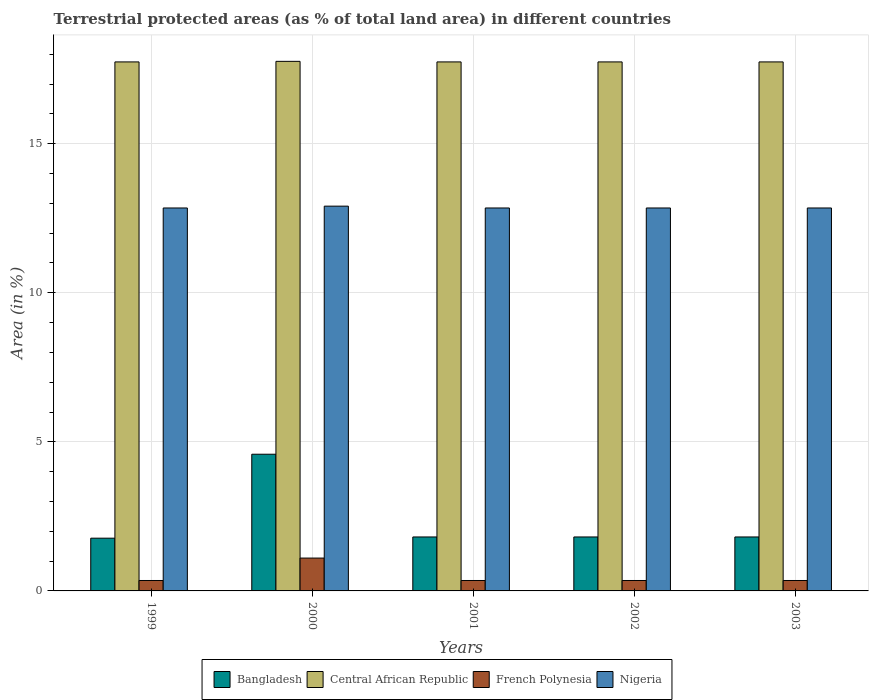Are the number of bars per tick equal to the number of legend labels?
Your answer should be compact. Yes. How many bars are there on the 5th tick from the right?
Offer a terse response. 4. In how many cases, is the number of bars for a given year not equal to the number of legend labels?
Keep it short and to the point. 0. What is the percentage of terrestrial protected land in Central African Republic in 2002?
Give a very brief answer. 17.74. Across all years, what is the maximum percentage of terrestrial protected land in Nigeria?
Your answer should be very brief. 12.91. Across all years, what is the minimum percentage of terrestrial protected land in French Polynesia?
Make the answer very short. 0.35. In which year was the percentage of terrestrial protected land in Nigeria maximum?
Your answer should be compact. 2000. What is the total percentage of terrestrial protected land in Central African Republic in the graph?
Keep it short and to the point. 88.74. What is the difference between the percentage of terrestrial protected land in Nigeria in 2001 and the percentage of terrestrial protected land in French Polynesia in 1999?
Your answer should be compact. 12.49. What is the average percentage of terrestrial protected land in Bangladesh per year?
Your answer should be very brief. 2.36. In the year 2000, what is the difference between the percentage of terrestrial protected land in Central African Republic and percentage of terrestrial protected land in Nigeria?
Your response must be concise. 4.86. What is the ratio of the percentage of terrestrial protected land in Nigeria in 1999 to that in 2002?
Keep it short and to the point. 1. Is the difference between the percentage of terrestrial protected land in Central African Republic in 2002 and 2003 greater than the difference between the percentage of terrestrial protected land in Nigeria in 2002 and 2003?
Offer a terse response. No. What is the difference between the highest and the second highest percentage of terrestrial protected land in Nigeria?
Offer a very short reply. 0.06. What is the difference between the highest and the lowest percentage of terrestrial protected land in Nigeria?
Provide a short and direct response. 0.06. Is it the case that in every year, the sum of the percentage of terrestrial protected land in Bangladesh and percentage of terrestrial protected land in Nigeria is greater than the sum of percentage of terrestrial protected land in French Polynesia and percentage of terrestrial protected land in Central African Republic?
Your response must be concise. No. What does the 1st bar from the left in 2000 represents?
Give a very brief answer. Bangladesh. What does the 3rd bar from the right in 1999 represents?
Your response must be concise. Central African Republic. How many years are there in the graph?
Your answer should be compact. 5. What is the difference between two consecutive major ticks on the Y-axis?
Offer a terse response. 5. Does the graph contain grids?
Offer a terse response. Yes. Where does the legend appear in the graph?
Ensure brevity in your answer.  Bottom center. What is the title of the graph?
Make the answer very short. Terrestrial protected areas (as % of total land area) in different countries. What is the label or title of the Y-axis?
Make the answer very short. Area (in %). What is the Area (in %) of Bangladesh in 1999?
Make the answer very short. 1.77. What is the Area (in %) of Central African Republic in 1999?
Keep it short and to the point. 17.74. What is the Area (in %) in French Polynesia in 1999?
Give a very brief answer. 0.35. What is the Area (in %) in Nigeria in 1999?
Keep it short and to the point. 12.84. What is the Area (in %) of Bangladesh in 2000?
Offer a very short reply. 4.58. What is the Area (in %) in Central African Republic in 2000?
Offer a very short reply. 17.76. What is the Area (in %) in French Polynesia in 2000?
Your answer should be very brief. 1.1. What is the Area (in %) of Nigeria in 2000?
Ensure brevity in your answer.  12.91. What is the Area (in %) of Bangladesh in 2001?
Give a very brief answer. 1.81. What is the Area (in %) in Central African Republic in 2001?
Make the answer very short. 17.74. What is the Area (in %) of French Polynesia in 2001?
Your answer should be very brief. 0.35. What is the Area (in %) of Nigeria in 2001?
Your response must be concise. 12.84. What is the Area (in %) of Bangladesh in 2002?
Your response must be concise. 1.81. What is the Area (in %) in Central African Republic in 2002?
Keep it short and to the point. 17.74. What is the Area (in %) in French Polynesia in 2002?
Ensure brevity in your answer.  0.35. What is the Area (in %) in Nigeria in 2002?
Your answer should be very brief. 12.84. What is the Area (in %) of Bangladesh in 2003?
Provide a succinct answer. 1.81. What is the Area (in %) in Central African Republic in 2003?
Make the answer very short. 17.74. What is the Area (in %) of French Polynesia in 2003?
Make the answer very short. 0.35. What is the Area (in %) in Nigeria in 2003?
Ensure brevity in your answer.  12.84. Across all years, what is the maximum Area (in %) in Bangladesh?
Provide a succinct answer. 4.58. Across all years, what is the maximum Area (in %) of Central African Republic?
Your answer should be compact. 17.76. Across all years, what is the maximum Area (in %) of French Polynesia?
Provide a short and direct response. 1.1. Across all years, what is the maximum Area (in %) of Nigeria?
Provide a short and direct response. 12.91. Across all years, what is the minimum Area (in %) in Bangladesh?
Your answer should be compact. 1.77. Across all years, what is the minimum Area (in %) in Central African Republic?
Offer a very short reply. 17.74. Across all years, what is the minimum Area (in %) in French Polynesia?
Offer a terse response. 0.35. Across all years, what is the minimum Area (in %) in Nigeria?
Offer a terse response. 12.84. What is the total Area (in %) of Bangladesh in the graph?
Keep it short and to the point. 11.78. What is the total Area (in %) of Central African Republic in the graph?
Ensure brevity in your answer.  88.74. What is the total Area (in %) in French Polynesia in the graph?
Offer a terse response. 2.5. What is the total Area (in %) of Nigeria in the graph?
Offer a terse response. 64.29. What is the difference between the Area (in %) in Bangladesh in 1999 and that in 2000?
Offer a very short reply. -2.82. What is the difference between the Area (in %) in Central African Republic in 1999 and that in 2000?
Offer a very short reply. -0.02. What is the difference between the Area (in %) of French Polynesia in 1999 and that in 2000?
Make the answer very short. -0.75. What is the difference between the Area (in %) of Nigeria in 1999 and that in 2000?
Your answer should be very brief. -0.06. What is the difference between the Area (in %) of Bangladesh in 1999 and that in 2001?
Your response must be concise. -0.04. What is the difference between the Area (in %) of Central African Republic in 1999 and that in 2001?
Your answer should be compact. 0. What is the difference between the Area (in %) in Nigeria in 1999 and that in 2001?
Provide a succinct answer. 0. What is the difference between the Area (in %) of Bangladesh in 1999 and that in 2002?
Keep it short and to the point. -0.04. What is the difference between the Area (in %) in Central African Republic in 1999 and that in 2002?
Provide a short and direct response. 0. What is the difference between the Area (in %) of French Polynesia in 1999 and that in 2002?
Offer a very short reply. 0. What is the difference between the Area (in %) in Bangladesh in 1999 and that in 2003?
Ensure brevity in your answer.  -0.04. What is the difference between the Area (in %) in French Polynesia in 1999 and that in 2003?
Offer a very short reply. 0. What is the difference between the Area (in %) in Nigeria in 1999 and that in 2003?
Your answer should be very brief. 0. What is the difference between the Area (in %) in Bangladesh in 2000 and that in 2001?
Keep it short and to the point. 2.77. What is the difference between the Area (in %) of Central African Republic in 2000 and that in 2001?
Give a very brief answer. 0.02. What is the difference between the Area (in %) of French Polynesia in 2000 and that in 2001?
Give a very brief answer. 0.75. What is the difference between the Area (in %) in Nigeria in 2000 and that in 2001?
Your response must be concise. 0.06. What is the difference between the Area (in %) of Bangladesh in 2000 and that in 2002?
Provide a succinct answer. 2.77. What is the difference between the Area (in %) in Central African Republic in 2000 and that in 2002?
Your answer should be very brief. 0.02. What is the difference between the Area (in %) in French Polynesia in 2000 and that in 2002?
Make the answer very short. 0.75. What is the difference between the Area (in %) in Nigeria in 2000 and that in 2002?
Your answer should be compact. 0.06. What is the difference between the Area (in %) of Bangladesh in 2000 and that in 2003?
Provide a short and direct response. 2.77. What is the difference between the Area (in %) of Central African Republic in 2000 and that in 2003?
Your response must be concise. 0.02. What is the difference between the Area (in %) of French Polynesia in 2000 and that in 2003?
Provide a succinct answer. 0.75. What is the difference between the Area (in %) of Nigeria in 2000 and that in 2003?
Provide a succinct answer. 0.06. What is the difference between the Area (in %) in Bangladesh in 2001 and that in 2002?
Provide a short and direct response. 0. What is the difference between the Area (in %) of French Polynesia in 2001 and that in 2002?
Keep it short and to the point. 0. What is the difference between the Area (in %) in Bangladesh in 2001 and that in 2003?
Provide a succinct answer. 0. What is the difference between the Area (in %) in Central African Republic in 2001 and that in 2003?
Provide a short and direct response. 0. What is the difference between the Area (in %) of French Polynesia in 2001 and that in 2003?
Give a very brief answer. 0. What is the difference between the Area (in %) of Bangladesh in 2002 and that in 2003?
Your answer should be compact. 0. What is the difference between the Area (in %) of Central African Republic in 2002 and that in 2003?
Your response must be concise. 0. What is the difference between the Area (in %) in French Polynesia in 2002 and that in 2003?
Provide a succinct answer. 0. What is the difference between the Area (in %) in Nigeria in 2002 and that in 2003?
Provide a short and direct response. 0. What is the difference between the Area (in %) in Bangladesh in 1999 and the Area (in %) in Central African Republic in 2000?
Make the answer very short. -15.99. What is the difference between the Area (in %) in Bangladesh in 1999 and the Area (in %) in French Polynesia in 2000?
Your answer should be compact. 0.67. What is the difference between the Area (in %) of Bangladesh in 1999 and the Area (in %) of Nigeria in 2000?
Your response must be concise. -11.14. What is the difference between the Area (in %) in Central African Republic in 1999 and the Area (in %) in French Polynesia in 2000?
Keep it short and to the point. 16.64. What is the difference between the Area (in %) of Central African Republic in 1999 and the Area (in %) of Nigeria in 2000?
Your answer should be compact. 4.84. What is the difference between the Area (in %) in French Polynesia in 1999 and the Area (in %) in Nigeria in 2000?
Your answer should be very brief. -12.56. What is the difference between the Area (in %) in Bangladesh in 1999 and the Area (in %) in Central African Republic in 2001?
Provide a short and direct response. -15.98. What is the difference between the Area (in %) in Bangladesh in 1999 and the Area (in %) in French Polynesia in 2001?
Offer a terse response. 1.42. What is the difference between the Area (in %) in Bangladesh in 1999 and the Area (in %) in Nigeria in 2001?
Your answer should be compact. -11.08. What is the difference between the Area (in %) of Central African Republic in 1999 and the Area (in %) of French Polynesia in 2001?
Ensure brevity in your answer.  17.39. What is the difference between the Area (in %) of Central African Republic in 1999 and the Area (in %) of Nigeria in 2001?
Your answer should be very brief. 4.9. What is the difference between the Area (in %) of French Polynesia in 1999 and the Area (in %) of Nigeria in 2001?
Offer a terse response. -12.49. What is the difference between the Area (in %) of Bangladesh in 1999 and the Area (in %) of Central African Republic in 2002?
Your answer should be compact. -15.98. What is the difference between the Area (in %) of Bangladesh in 1999 and the Area (in %) of French Polynesia in 2002?
Your answer should be compact. 1.42. What is the difference between the Area (in %) of Bangladesh in 1999 and the Area (in %) of Nigeria in 2002?
Give a very brief answer. -11.08. What is the difference between the Area (in %) in Central African Republic in 1999 and the Area (in %) in French Polynesia in 2002?
Offer a terse response. 17.39. What is the difference between the Area (in %) of Central African Republic in 1999 and the Area (in %) of Nigeria in 2002?
Offer a terse response. 4.9. What is the difference between the Area (in %) in French Polynesia in 1999 and the Area (in %) in Nigeria in 2002?
Keep it short and to the point. -12.49. What is the difference between the Area (in %) in Bangladesh in 1999 and the Area (in %) in Central African Republic in 2003?
Your response must be concise. -15.98. What is the difference between the Area (in %) in Bangladesh in 1999 and the Area (in %) in French Polynesia in 2003?
Offer a terse response. 1.42. What is the difference between the Area (in %) in Bangladesh in 1999 and the Area (in %) in Nigeria in 2003?
Your answer should be compact. -11.08. What is the difference between the Area (in %) of Central African Republic in 1999 and the Area (in %) of French Polynesia in 2003?
Offer a terse response. 17.39. What is the difference between the Area (in %) of Central African Republic in 1999 and the Area (in %) of Nigeria in 2003?
Provide a succinct answer. 4.9. What is the difference between the Area (in %) in French Polynesia in 1999 and the Area (in %) in Nigeria in 2003?
Your answer should be very brief. -12.49. What is the difference between the Area (in %) of Bangladesh in 2000 and the Area (in %) of Central African Republic in 2001?
Ensure brevity in your answer.  -13.16. What is the difference between the Area (in %) in Bangladesh in 2000 and the Area (in %) in French Polynesia in 2001?
Your answer should be compact. 4.23. What is the difference between the Area (in %) in Bangladesh in 2000 and the Area (in %) in Nigeria in 2001?
Your response must be concise. -8.26. What is the difference between the Area (in %) in Central African Republic in 2000 and the Area (in %) in French Polynesia in 2001?
Your response must be concise. 17.41. What is the difference between the Area (in %) in Central African Republic in 2000 and the Area (in %) in Nigeria in 2001?
Provide a short and direct response. 4.92. What is the difference between the Area (in %) in French Polynesia in 2000 and the Area (in %) in Nigeria in 2001?
Your response must be concise. -11.74. What is the difference between the Area (in %) of Bangladesh in 2000 and the Area (in %) of Central African Republic in 2002?
Give a very brief answer. -13.16. What is the difference between the Area (in %) in Bangladesh in 2000 and the Area (in %) in French Polynesia in 2002?
Your answer should be compact. 4.23. What is the difference between the Area (in %) in Bangladesh in 2000 and the Area (in %) in Nigeria in 2002?
Offer a terse response. -8.26. What is the difference between the Area (in %) in Central African Republic in 2000 and the Area (in %) in French Polynesia in 2002?
Offer a terse response. 17.41. What is the difference between the Area (in %) of Central African Republic in 2000 and the Area (in %) of Nigeria in 2002?
Your answer should be compact. 4.92. What is the difference between the Area (in %) of French Polynesia in 2000 and the Area (in %) of Nigeria in 2002?
Your response must be concise. -11.74. What is the difference between the Area (in %) in Bangladesh in 2000 and the Area (in %) in Central African Republic in 2003?
Your answer should be compact. -13.16. What is the difference between the Area (in %) in Bangladesh in 2000 and the Area (in %) in French Polynesia in 2003?
Your answer should be very brief. 4.23. What is the difference between the Area (in %) of Bangladesh in 2000 and the Area (in %) of Nigeria in 2003?
Ensure brevity in your answer.  -8.26. What is the difference between the Area (in %) of Central African Republic in 2000 and the Area (in %) of French Polynesia in 2003?
Make the answer very short. 17.41. What is the difference between the Area (in %) of Central African Republic in 2000 and the Area (in %) of Nigeria in 2003?
Your answer should be compact. 4.92. What is the difference between the Area (in %) of French Polynesia in 2000 and the Area (in %) of Nigeria in 2003?
Ensure brevity in your answer.  -11.74. What is the difference between the Area (in %) of Bangladesh in 2001 and the Area (in %) of Central African Republic in 2002?
Give a very brief answer. -15.93. What is the difference between the Area (in %) in Bangladesh in 2001 and the Area (in %) in French Polynesia in 2002?
Your answer should be compact. 1.46. What is the difference between the Area (in %) of Bangladesh in 2001 and the Area (in %) of Nigeria in 2002?
Make the answer very short. -11.03. What is the difference between the Area (in %) in Central African Republic in 2001 and the Area (in %) in French Polynesia in 2002?
Your response must be concise. 17.39. What is the difference between the Area (in %) of Central African Republic in 2001 and the Area (in %) of Nigeria in 2002?
Provide a short and direct response. 4.9. What is the difference between the Area (in %) of French Polynesia in 2001 and the Area (in %) of Nigeria in 2002?
Your answer should be compact. -12.49. What is the difference between the Area (in %) of Bangladesh in 2001 and the Area (in %) of Central African Republic in 2003?
Offer a very short reply. -15.93. What is the difference between the Area (in %) of Bangladesh in 2001 and the Area (in %) of French Polynesia in 2003?
Provide a succinct answer. 1.46. What is the difference between the Area (in %) in Bangladesh in 2001 and the Area (in %) in Nigeria in 2003?
Your answer should be compact. -11.03. What is the difference between the Area (in %) in Central African Republic in 2001 and the Area (in %) in French Polynesia in 2003?
Your response must be concise. 17.39. What is the difference between the Area (in %) of Central African Republic in 2001 and the Area (in %) of Nigeria in 2003?
Ensure brevity in your answer.  4.9. What is the difference between the Area (in %) of French Polynesia in 2001 and the Area (in %) of Nigeria in 2003?
Make the answer very short. -12.49. What is the difference between the Area (in %) of Bangladesh in 2002 and the Area (in %) of Central African Republic in 2003?
Offer a very short reply. -15.93. What is the difference between the Area (in %) of Bangladesh in 2002 and the Area (in %) of French Polynesia in 2003?
Your response must be concise. 1.46. What is the difference between the Area (in %) of Bangladesh in 2002 and the Area (in %) of Nigeria in 2003?
Offer a very short reply. -11.03. What is the difference between the Area (in %) of Central African Republic in 2002 and the Area (in %) of French Polynesia in 2003?
Offer a very short reply. 17.39. What is the difference between the Area (in %) in Central African Republic in 2002 and the Area (in %) in Nigeria in 2003?
Provide a short and direct response. 4.9. What is the difference between the Area (in %) in French Polynesia in 2002 and the Area (in %) in Nigeria in 2003?
Your answer should be compact. -12.49. What is the average Area (in %) of Bangladesh per year?
Keep it short and to the point. 2.36. What is the average Area (in %) in Central African Republic per year?
Your answer should be very brief. 17.75. What is the average Area (in %) in French Polynesia per year?
Keep it short and to the point. 0.5. What is the average Area (in %) in Nigeria per year?
Ensure brevity in your answer.  12.86. In the year 1999, what is the difference between the Area (in %) in Bangladesh and Area (in %) in Central African Republic?
Offer a terse response. -15.98. In the year 1999, what is the difference between the Area (in %) of Bangladesh and Area (in %) of French Polynesia?
Your answer should be very brief. 1.42. In the year 1999, what is the difference between the Area (in %) in Bangladesh and Area (in %) in Nigeria?
Offer a terse response. -11.08. In the year 1999, what is the difference between the Area (in %) of Central African Republic and Area (in %) of French Polynesia?
Offer a very short reply. 17.39. In the year 1999, what is the difference between the Area (in %) of Central African Republic and Area (in %) of Nigeria?
Give a very brief answer. 4.9. In the year 1999, what is the difference between the Area (in %) of French Polynesia and Area (in %) of Nigeria?
Offer a very short reply. -12.49. In the year 2000, what is the difference between the Area (in %) of Bangladesh and Area (in %) of Central African Republic?
Provide a succinct answer. -13.18. In the year 2000, what is the difference between the Area (in %) of Bangladesh and Area (in %) of French Polynesia?
Offer a very short reply. 3.48. In the year 2000, what is the difference between the Area (in %) in Bangladesh and Area (in %) in Nigeria?
Offer a very short reply. -8.32. In the year 2000, what is the difference between the Area (in %) in Central African Republic and Area (in %) in French Polynesia?
Offer a terse response. 16.66. In the year 2000, what is the difference between the Area (in %) in Central African Republic and Area (in %) in Nigeria?
Your response must be concise. 4.86. In the year 2000, what is the difference between the Area (in %) of French Polynesia and Area (in %) of Nigeria?
Offer a terse response. -11.8. In the year 2001, what is the difference between the Area (in %) in Bangladesh and Area (in %) in Central African Republic?
Your response must be concise. -15.93. In the year 2001, what is the difference between the Area (in %) in Bangladesh and Area (in %) in French Polynesia?
Your answer should be compact. 1.46. In the year 2001, what is the difference between the Area (in %) of Bangladesh and Area (in %) of Nigeria?
Give a very brief answer. -11.03. In the year 2001, what is the difference between the Area (in %) of Central African Republic and Area (in %) of French Polynesia?
Your response must be concise. 17.39. In the year 2001, what is the difference between the Area (in %) of Central African Republic and Area (in %) of Nigeria?
Ensure brevity in your answer.  4.9. In the year 2001, what is the difference between the Area (in %) in French Polynesia and Area (in %) in Nigeria?
Keep it short and to the point. -12.49. In the year 2002, what is the difference between the Area (in %) in Bangladesh and Area (in %) in Central African Republic?
Provide a short and direct response. -15.93. In the year 2002, what is the difference between the Area (in %) of Bangladesh and Area (in %) of French Polynesia?
Give a very brief answer. 1.46. In the year 2002, what is the difference between the Area (in %) of Bangladesh and Area (in %) of Nigeria?
Give a very brief answer. -11.03. In the year 2002, what is the difference between the Area (in %) in Central African Republic and Area (in %) in French Polynesia?
Provide a short and direct response. 17.39. In the year 2002, what is the difference between the Area (in %) in Central African Republic and Area (in %) in Nigeria?
Make the answer very short. 4.9. In the year 2002, what is the difference between the Area (in %) of French Polynesia and Area (in %) of Nigeria?
Your response must be concise. -12.49. In the year 2003, what is the difference between the Area (in %) of Bangladesh and Area (in %) of Central African Republic?
Keep it short and to the point. -15.93. In the year 2003, what is the difference between the Area (in %) in Bangladesh and Area (in %) in French Polynesia?
Offer a terse response. 1.46. In the year 2003, what is the difference between the Area (in %) of Bangladesh and Area (in %) of Nigeria?
Keep it short and to the point. -11.03. In the year 2003, what is the difference between the Area (in %) of Central African Republic and Area (in %) of French Polynesia?
Keep it short and to the point. 17.39. In the year 2003, what is the difference between the Area (in %) of Central African Republic and Area (in %) of Nigeria?
Your answer should be compact. 4.9. In the year 2003, what is the difference between the Area (in %) in French Polynesia and Area (in %) in Nigeria?
Give a very brief answer. -12.49. What is the ratio of the Area (in %) of Bangladesh in 1999 to that in 2000?
Provide a succinct answer. 0.39. What is the ratio of the Area (in %) in French Polynesia in 1999 to that in 2000?
Your response must be concise. 0.32. What is the ratio of the Area (in %) of Bangladesh in 1999 to that in 2001?
Keep it short and to the point. 0.98. What is the ratio of the Area (in %) of Central African Republic in 1999 to that in 2001?
Your response must be concise. 1. What is the ratio of the Area (in %) of Bangladesh in 1999 to that in 2002?
Ensure brevity in your answer.  0.98. What is the ratio of the Area (in %) in Bangladesh in 1999 to that in 2003?
Make the answer very short. 0.98. What is the ratio of the Area (in %) in French Polynesia in 1999 to that in 2003?
Your answer should be very brief. 1. What is the ratio of the Area (in %) in Bangladesh in 2000 to that in 2001?
Give a very brief answer. 2.53. What is the ratio of the Area (in %) of French Polynesia in 2000 to that in 2001?
Offer a terse response. 3.15. What is the ratio of the Area (in %) of Bangladesh in 2000 to that in 2002?
Provide a short and direct response. 2.53. What is the ratio of the Area (in %) in French Polynesia in 2000 to that in 2002?
Give a very brief answer. 3.15. What is the ratio of the Area (in %) in Nigeria in 2000 to that in 2002?
Give a very brief answer. 1. What is the ratio of the Area (in %) in Bangladesh in 2000 to that in 2003?
Give a very brief answer. 2.53. What is the ratio of the Area (in %) in Central African Republic in 2000 to that in 2003?
Your answer should be compact. 1. What is the ratio of the Area (in %) in French Polynesia in 2000 to that in 2003?
Give a very brief answer. 3.15. What is the ratio of the Area (in %) in Nigeria in 2000 to that in 2003?
Make the answer very short. 1. What is the ratio of the Area (in %) in French Polynesia in 2001 to that in 2002?
Give a very brief answer. 1. What is the ratio of the Area (in %) in Nigeria in 2001 to that in 2002?
Keep it short and to the point. 1. What is the ratio of the Area (in %) of Nigeria in 2001 to that in 2003?
Your answer should be very brief. 1. What is the difference between the highest and the second highest Area (in %) in Bangladesh?
Give a very brief answer. 2.77. What is the difference between the highest and the second highest Area (in %) of Central African Republic?
Your answer should be compact. 0.02. What is the difference between the highest and the second highest Area (in %) of French Polynesia?
Ensure brevity in your answer.  0.75. What is the difference between the highest and the second highest Area (in %) of Nigeria?
Ensure brevity in your answer.  0.06. What is the difference between the highest and the lowest Area (in %) in Bangladesh?
Make the answer very short. 2.82. What is the difference between the highest and the lowest Area (in %) of Central African Republic?
Your answer should be compact. 0.02. What is the difference between the highest and the lowest Area (in %) in French Polynesia?
Your response must be concise. 0.75. What is the difference between the highest and the lowest Area (in %) in Nigeria?
Give a very brief answer. 0.06. 